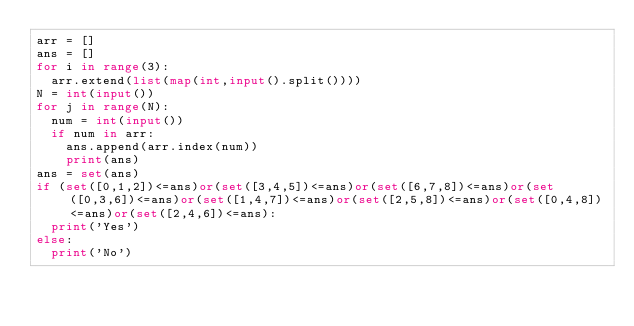Convert code to text. <code><loc_0><loc_0><loc_500><loc_500><_Python_>arr = []
ans = []
for i in range(3):
  arr.extend(list(map(int,input().split())))
N = int(input())
for j in range(N):
  num = int(input())
  if num in arr:
    ans.append(arr.index(num))
    print(ans)
ans = set(ans)
if (set([0,1,2])<=ans)or(set([3,4,5])<=ans)or(set([6,7,8])<=ans)or(set([0,3,6])<=ans)or(set([1,4,7])<=ans)or(set([2,5,8])<=ans)or(set([0,4,8])<=ans)or(set([2,4,6])<=ans):
  print('Yes')
else:
  print('No')
</code> 